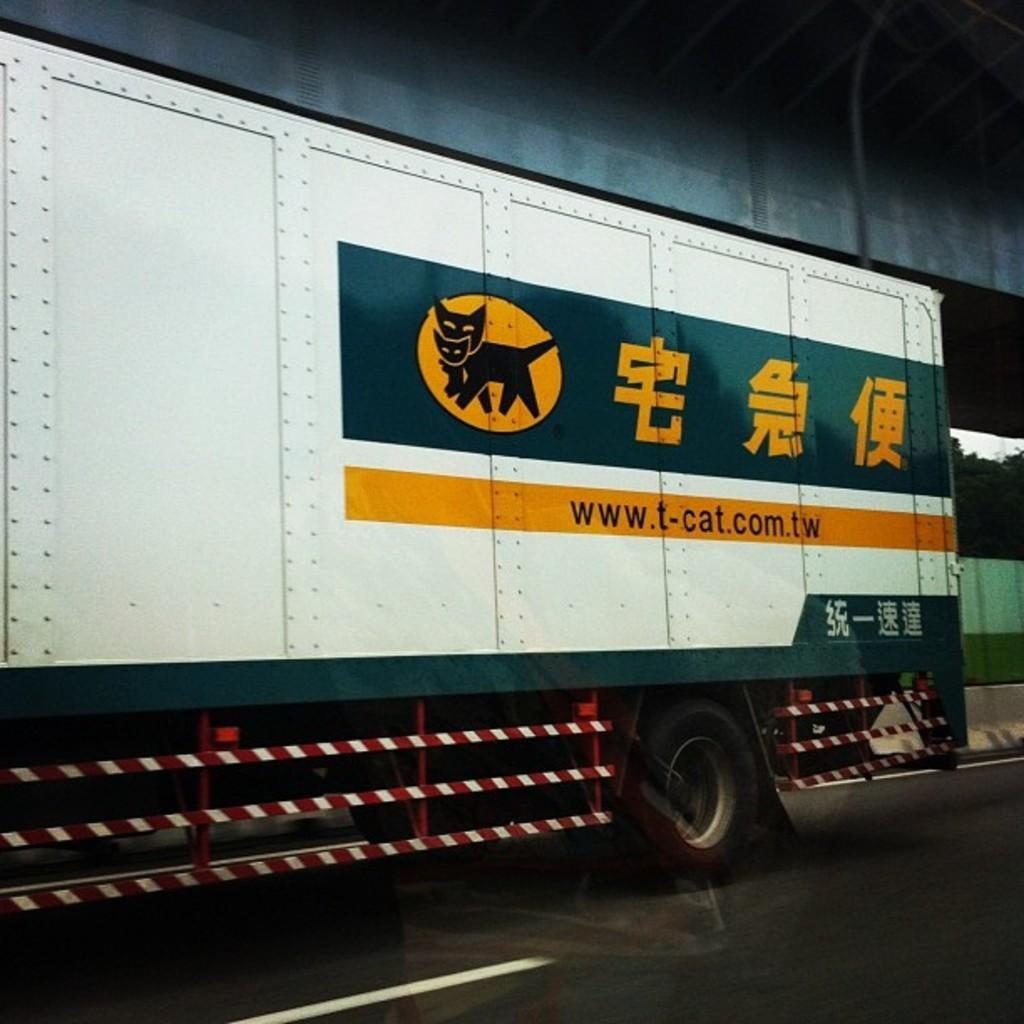What is the main subject in the center of the image? There is a truck in the center of the image. What can be seen in the background of the image? There are trees in the background of the image. What is located at the top side of the image? There is a roof at the top side of the image. What type of collar can be seen on the truck in the image? There is no collar present on the truck in the image. How many apples are visible on the roof in the image? There are no apples present in the image. 